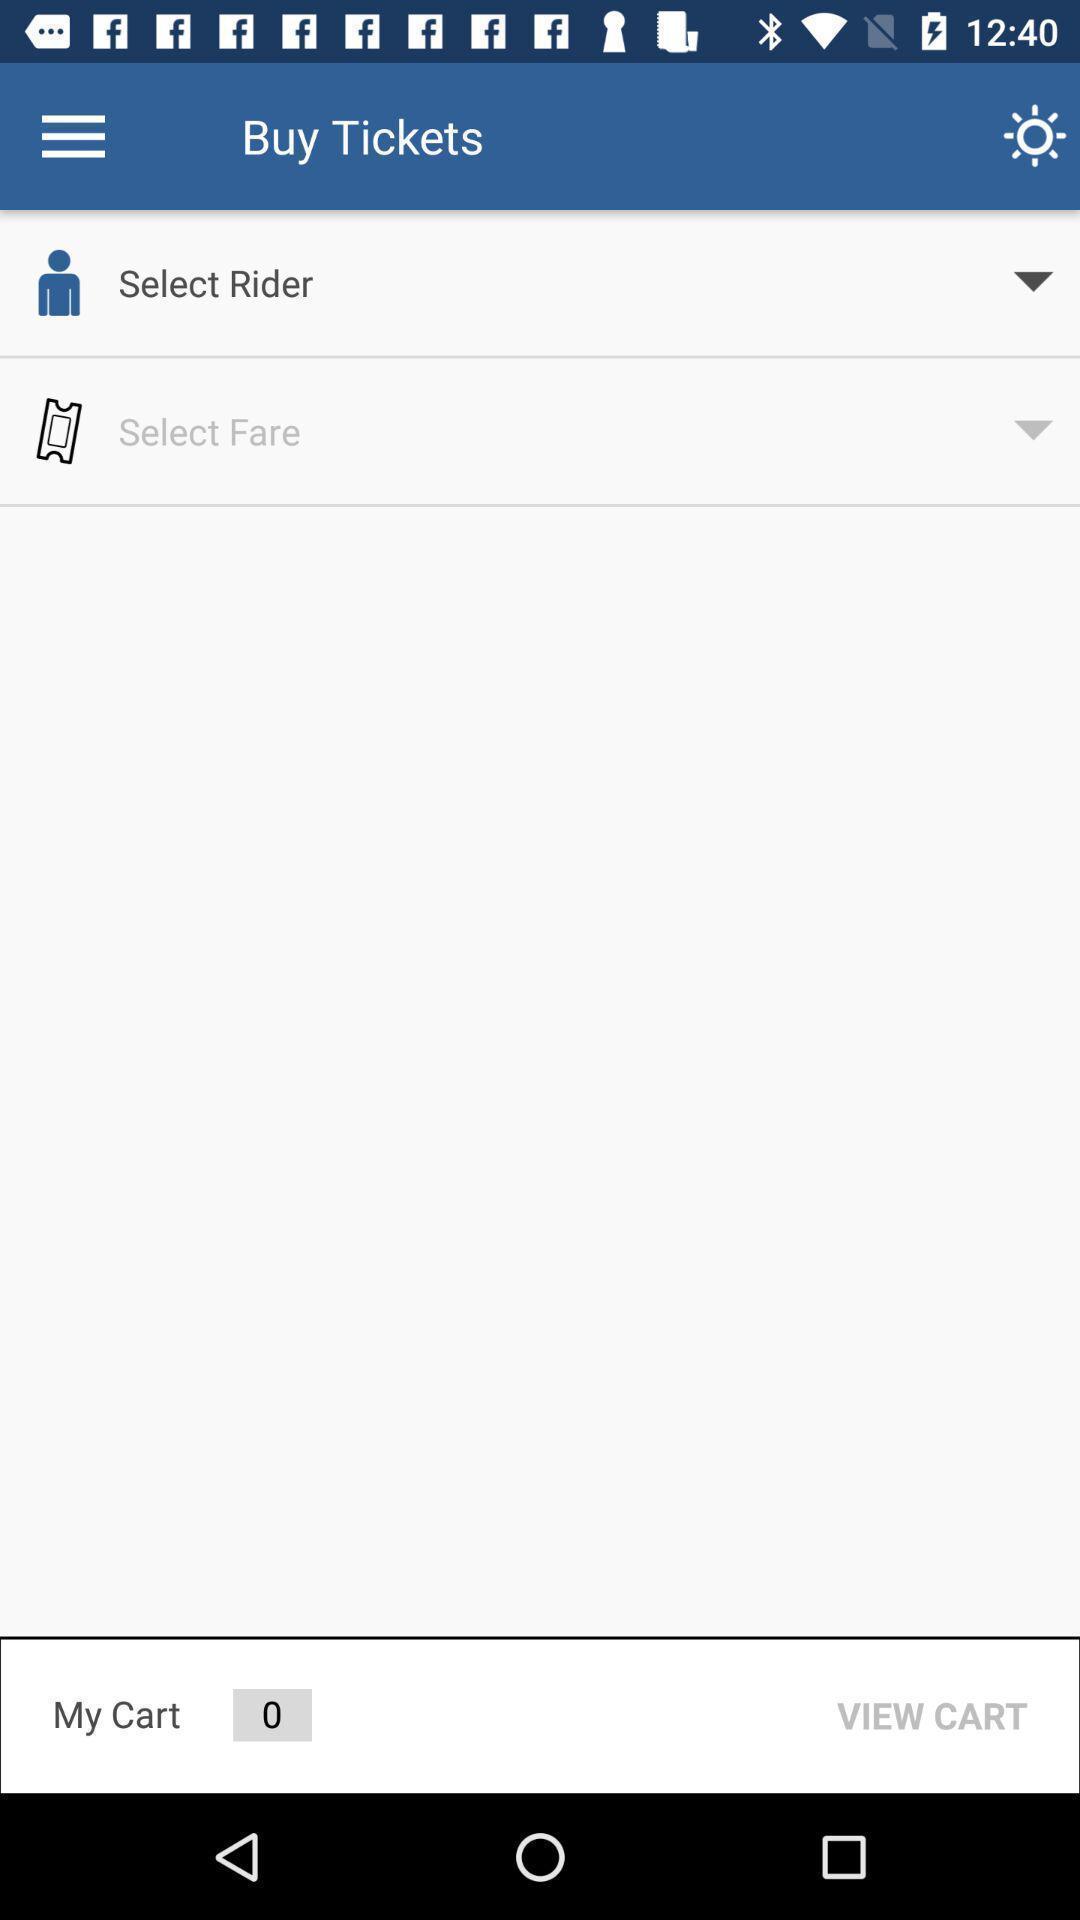Explain what's happening in this screen capture. Screen showing option to select rider. 